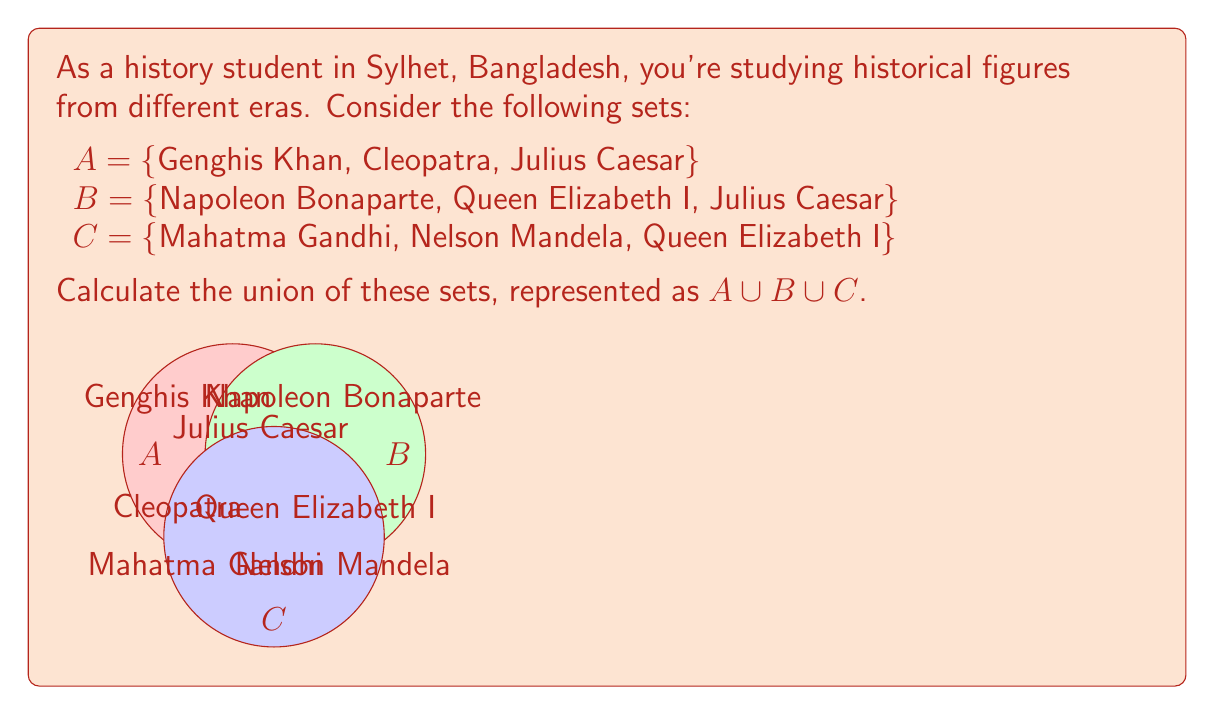Give your solution to this math problem. To find the union of sets A, B, and C, we need to list all unique elements from all three sets. Let's approach this step-by-step:

1) First, let's list all elements from set A:
   {Genghis Khan, Cleopatra, Julius Caesar}

2) Next, we add any new elements from set B that are not already in our list:
   - Napoleon Bonaparte is new, so we add it
   - Queen Elizabeth I is new, so we add it
   - Julius Caesar is already in the list, so we don't add it again

   Our list now: {Genghis Khan, Cleopatra, Julius Caesar, Napoleon Bonaparte, Queen Elizabeth I}

3) Finally, we add any new elements from set C:
   - Mahatma Gandhi is new, so we add it
   - Nelson Mandela is new, so we add it
   - Queen Elizabeth I is already in the list, so we don't add it again

4) Our final union is:
   $A \cup B \cup C$ = {Genghis Khan, Cleopatra, Julius Caesar, Napoleon Bonaparte, Queen Elizabeth I, Mahatma Gandhi, Nelson Mandela}

5) We can verify that this set contains all elements from A, B, and C, and each element appears only once.

The number of elements in the union is 7, which we can write as $|A \cup B \cup C| = 7$.
Answer: $A \cup B \cup C$ = {Genghis Khan, Cleopatra, Julius Caesar, Napoleon Bonaparte, Queen Elizabeth I, Mahatma Gandhi, Nelson Mandela} 